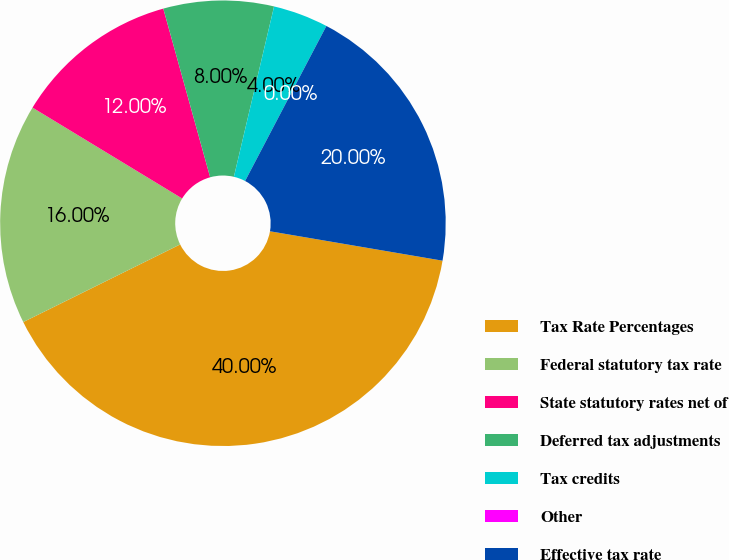Convert chart. <chart><loc_0><loc_0><loc_500><loc_500><pie_chart><fcel>Tax Rate Percentages<fcel>Federal statutory tax rate<fcel>State statutory rates net of<fcel>Deferred tax adjustments<fcel>Tax credits<fcel>Other<fcel>Effective tax rate<nl><fcel>40.0%<fcel>16.0%<fcel>12.0%<fcel>8.0%<fcel>4.0%<fcel>0.0%<fcel>20.0%<nl></chart> 